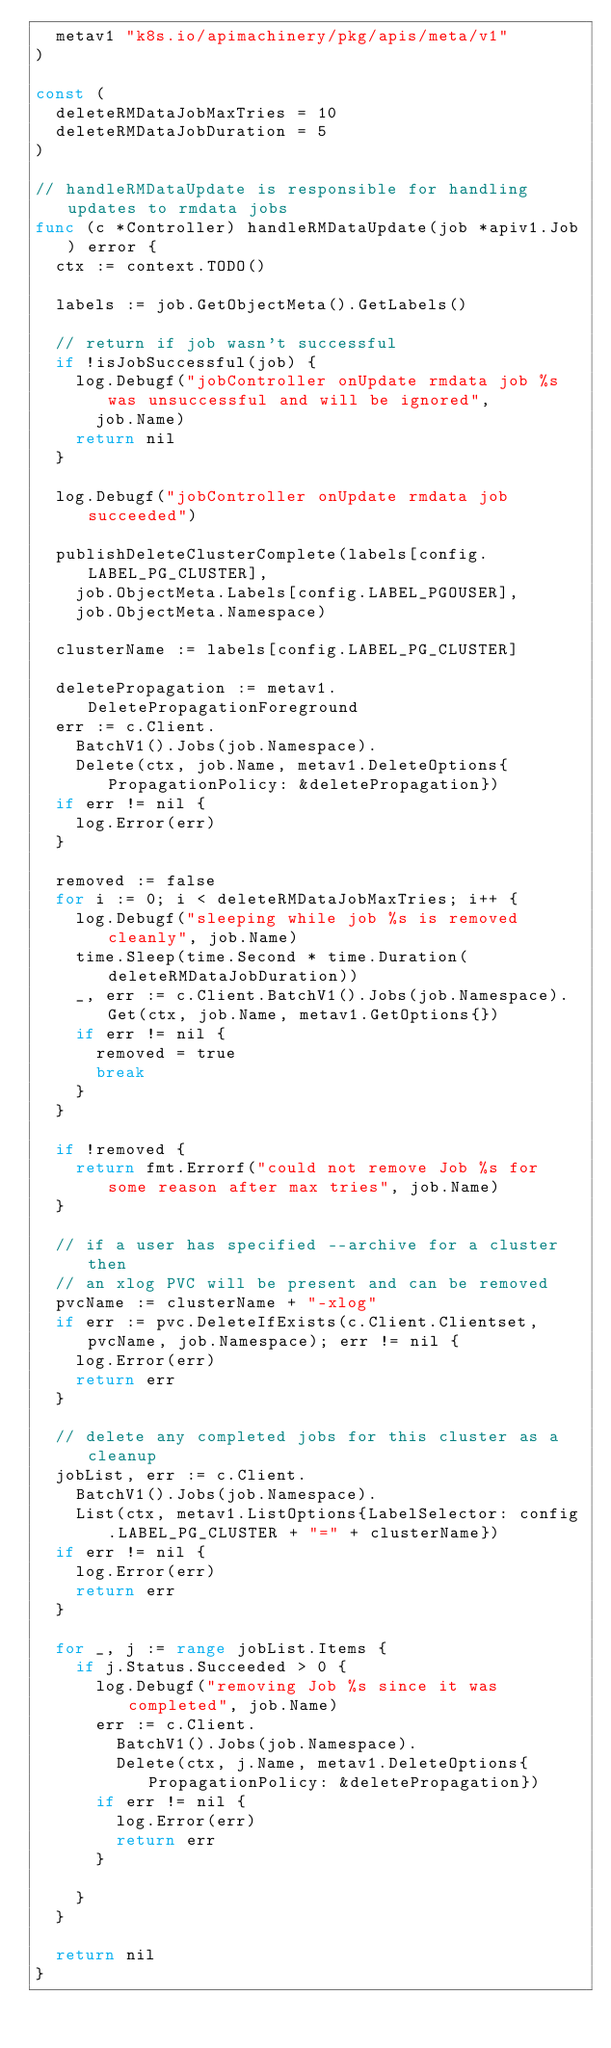<code> <loc_0><loc_0><loc_500><loc_500><_Go_>	metav1 "k8s.io/apimachinery/pkg/apis/meta/v1"
)

const (
	deleteRMDataJobMaxTries = 10
	deleteRMDataJobDuration = 5
)

// handleRMDataUpdate is responsible for handling updates to rmdata jobs
func (c *Controller) handleRMDataUpdate(job *apiv1.Job) error {
	ctx := context.TODO()

	labels := job.GetObjectMeta().GetLabels()

	// return if job wasn't successful
	if !isJobSuccessful(job) {
		log.Debugf("jobController onUpdate rmdata job %s was unsuccessful and will be ignored",
			job.Name)
		return nil
	}

	log.Debugf("jobController onUpdate rmdata job succeeded")

	publishDeleteClusterComplete(labels[config.LABEL_PG_CLUSTER],
		job.ObjectMeta.Labels[config.LABEL_PGOUSER],
		job.ObjectMeta.Namespace)

	clusterName := labels[config.LABEL_PG_CLUSTER]

	deletePropagation := metav1.DeletePropagationForeground
	err := c.Client.
		BatchV1().Jobs(job.Namespace).
		Delete(ctx, job.Name, metav1.DeleteOptions{PropagationPolicy: &deletePropagation})
	if err != nil {
		log.Error(err)
	}

	removed := false
	for i := 0; i < deleteRMDataJobMaxTries; i++ {
		log.Debugf("sleeping while job %s is removed cleanly", job.Name)
		time.Sleep(time.Second * time.Duration(deleteRMDataJobDuration))
		_, err := c.Client.BatchV1().Jobs(job.Namespace).Get(ctx, job.Name, metav1.GetOptions{})
		if err != nil {
			removed = true
			break
		}
	}

	if !removed {
		return fmt.Errorf("could not remove Job %s for some reason after max tries", job.Name)
	}

	// if a user has specified --archive for a cluster then
	// an xlog PVC will be present and can be removed
	pvcName := clusterName + "-xlog"
	if err := pvc.DeleteIfExists(c.Client.Clientset, pvcName, job.Namespace); err != nil {
		log.Error(err)
		return err
	}

	// delete any completed jobs for this cluster as a cleanup
	jobList, err := c.Client.
		BatchV1().Jobs(job.Namespace).
		List(ctx, metav1.ListOptions{LabelSelector: config.LABEL_PG_CLUSTER + "=" + clusterName})
	if err != nil {
		log.Error(err)
		return err
	}

	for _, j := range jobList.Items {
		if j.Status.Succeeded > 0 {
			log.Debugf("removing Job %s since it was completed", job.Name)
			err := c.Client.
				BatchV1().Jobs(job.Namespace).
				Delete(ctx, j.Name, metav1.DeleteOptions{PropagationPolicy: &deletePropagation})
			if err != nil {
				log.Error(err)
				return err
			}

		}
	}

	return nil
}
</code> 